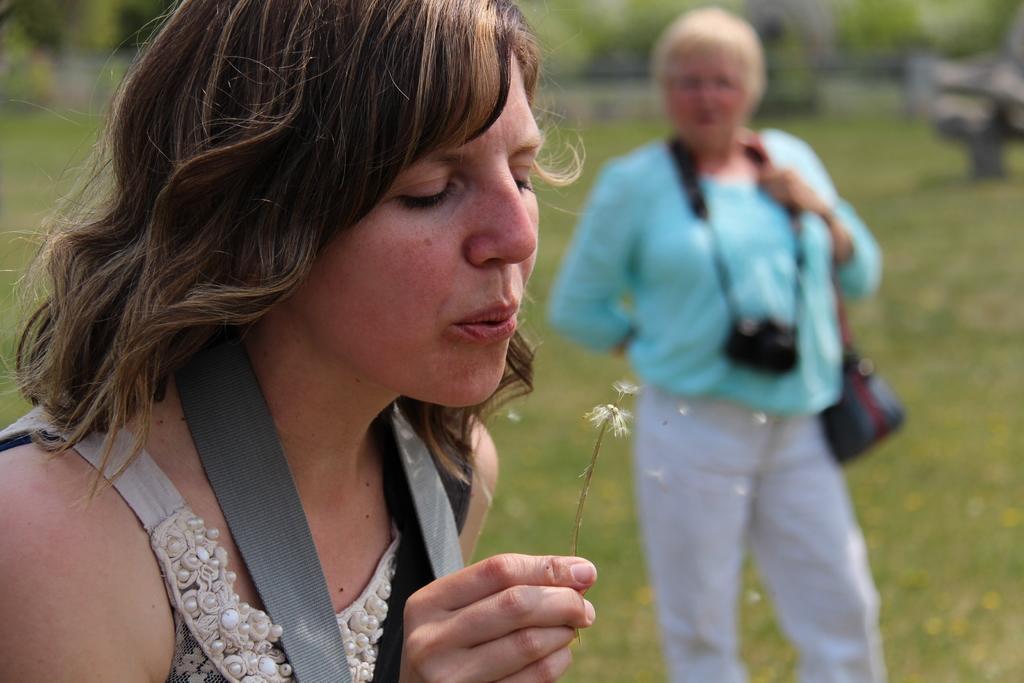Please provide a concise description of this image. In this picture we can observe a woman, holding a flower in her hand. She is blowing a flower. We can observe another woman on the right side. She is wearing blue color T shirt and a camera in her neck. We can observe some grass on the ground. In the background there are trees. 